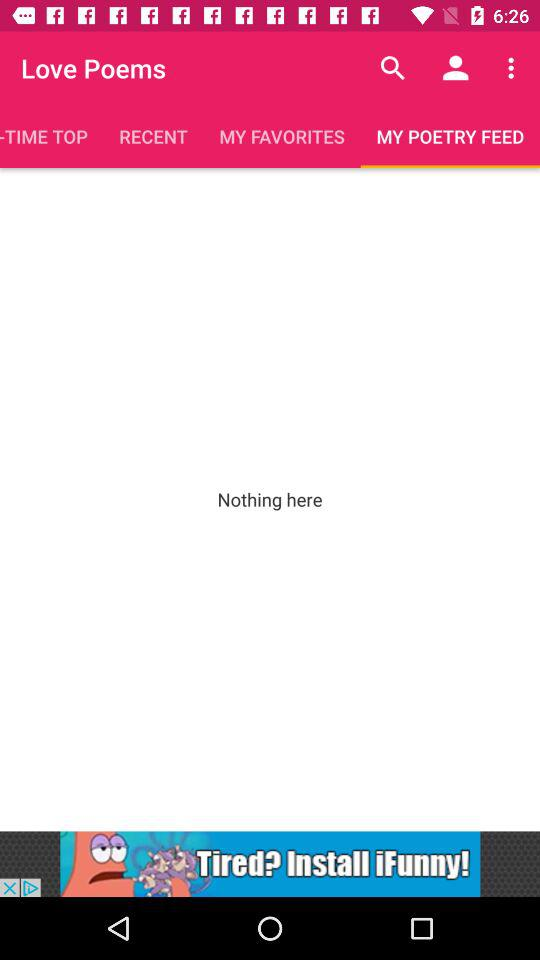What is the application name? The application name is "Love Poems". 